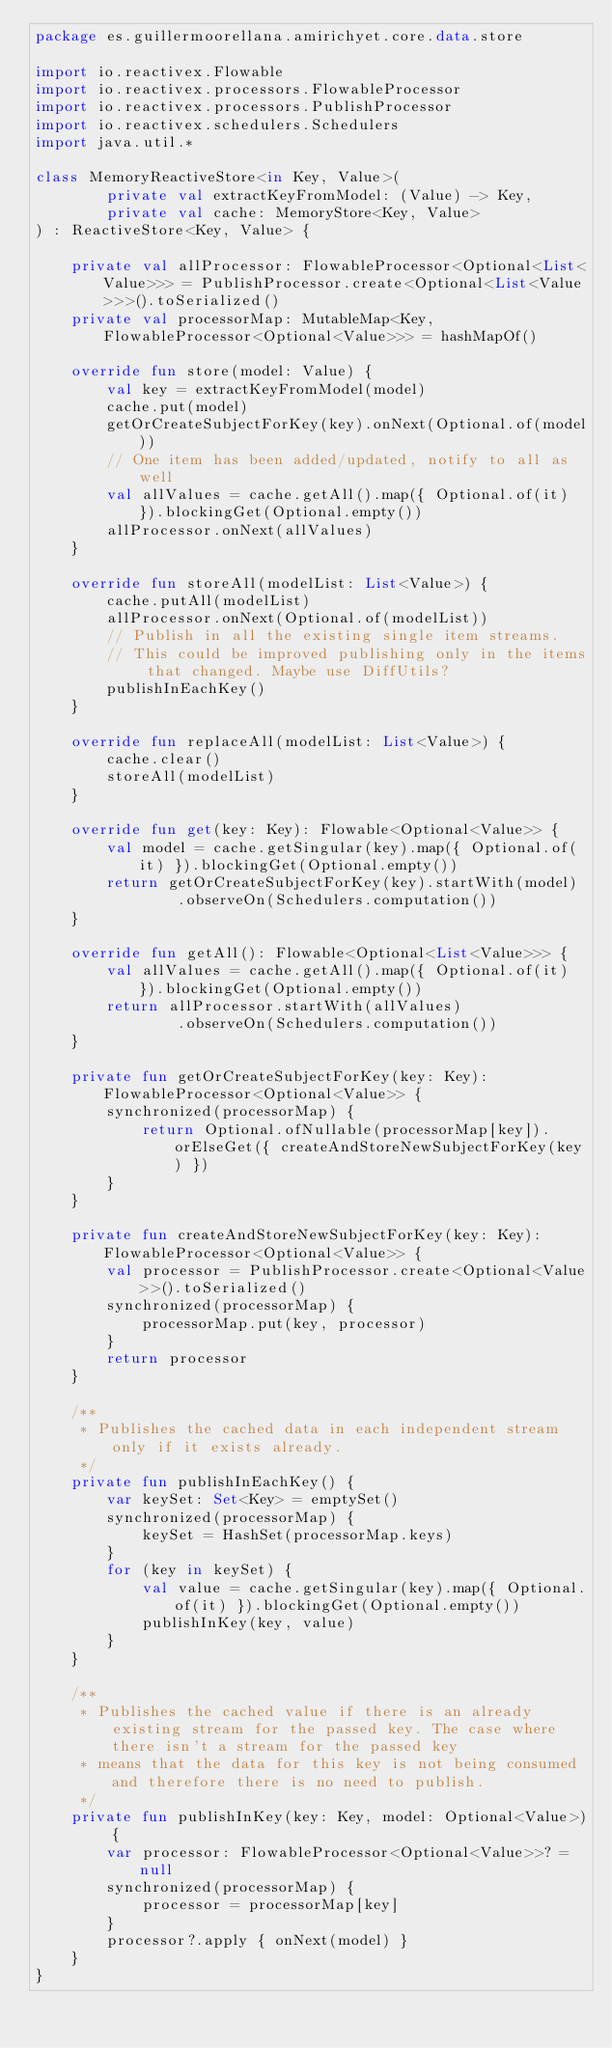Convert code to text. <code><loc_0><loc_0><loc_500><loc_500><_Kotlin_>package es.guillermoorellana.amirichyet.core.data.store

import io.reactivex.Flowable
import io.reactivex.processors.FlowableProcessor
import io.reactivex.processors.PublishProcessor
import io.reactivex.schedulers.Schedulers
import java.util.*

class MemoryReactiveStore<in Key, Value>(
        private val extractKeyFromModel: (Value) -> Key,
        private val cache: MemoryStore<Key, Value>
) : ReactiveStore<Key, Value> {

    private val allProcessor: FlowableProcessor<Optional<List<Value>>> = PublishProcessor.create<Optional<List<Value>>>().toSerialized()
    private val processorMap: MutableMap<Key, FlowableProcessor<Optional<Value>>> = hashMapOf()

    override fun store(model: Value) {
        val key = extractKeyFromModel(model)
        cache.put(model)
        getOrCreateSubjectForKey(key).onNext(Optional.of(model))
        // One item has been added/updated, notify to all as well
        val allValues = cache.getAll().map({ Optional.of(it) }).blockingGet(Optional.empty())
        allProcessor.onNext(allValues)
    }

    override fun storeAll(modelList: List<Value>) {
        cache.putAll(modelList)
        allProcessor.onNext(Optional.of(modelList))
        // Publish in all the existing single item streams.
        // This could be improved publishing only in the items that changed. Maybe use DiffUtils?
        publishInEachKey()
    }

    override fun replaceAll(modelList: List<Value>) {
        cache.clear()
        storeAll(modelList)
    }

    override fun get(key: Key): Flowable<Optional<Value>> {
        val model = cache.getSingular(key).map({ Optional.of(it) }).blockingGet(Optional.empty())
        return getOrCreateSubjectForKey(key).startWith(model)
                .observeOn(Schedulers.computation())
    }

    override fun getAll(): Flowable<Optional<List<Value>>> {
        val allValues = cache.getAll().map({ Optional.of(it) }).blockingGet(Optional.empty())
        return allProcessor.startWith(allValues)
                .observeOn(Schedulers.computation())
    }

    private fun getOrCreateSubjectForKey(key: Key): FlowableProcessor<Optional<Value>> {
        synchronized(processorMap) {
            return Optional.ofNullable(processorMap[key]).orElseGet({ createAndStoreNewSubjectForKey(key) })
        }
    }

    private fun createAndStoreNewSubjectForKey(key: Key): FlowableProcessor<Optional<Value>> {
        val processor = PublishProcessor.create<Optional<Value>>().toSerialized()
        synchronized(processorMap) {
            processorMap.put(key, processor)
        }
        return processor
    }

    /**
     * Publishes the cached data in each independent stream only if it exists already.
     */
    private fun publishInEachKey() {
        var keySet: Set<Key> = emptySet()
        synchronized(processorMap) {
            keySet = HashSet(processorMap.keys)
        }
        for (key in keySet) {
            val value = cache.getSingular(key).map({ Optional.of(it) }).blockingGet(Optional.empty())
            publishInKey(key, value)
        }
    }

    /**
     * Publishes the cached value if there is an already existing stream for the passed key. The case where there isn't a stream for the passed key
     * means that the data for this key is not being consumed and therefore there is no need to publish.
     */
    private fun publishInKey(key: Key, model: Optional<Value>) {
        var processor: FlowableProcessor<Optional<Value>>? = null
        synchronized(processorMap) {
            processor = processorMap[key]
        }
        processor?.apply { onNext(model) }
    }
}</code> 